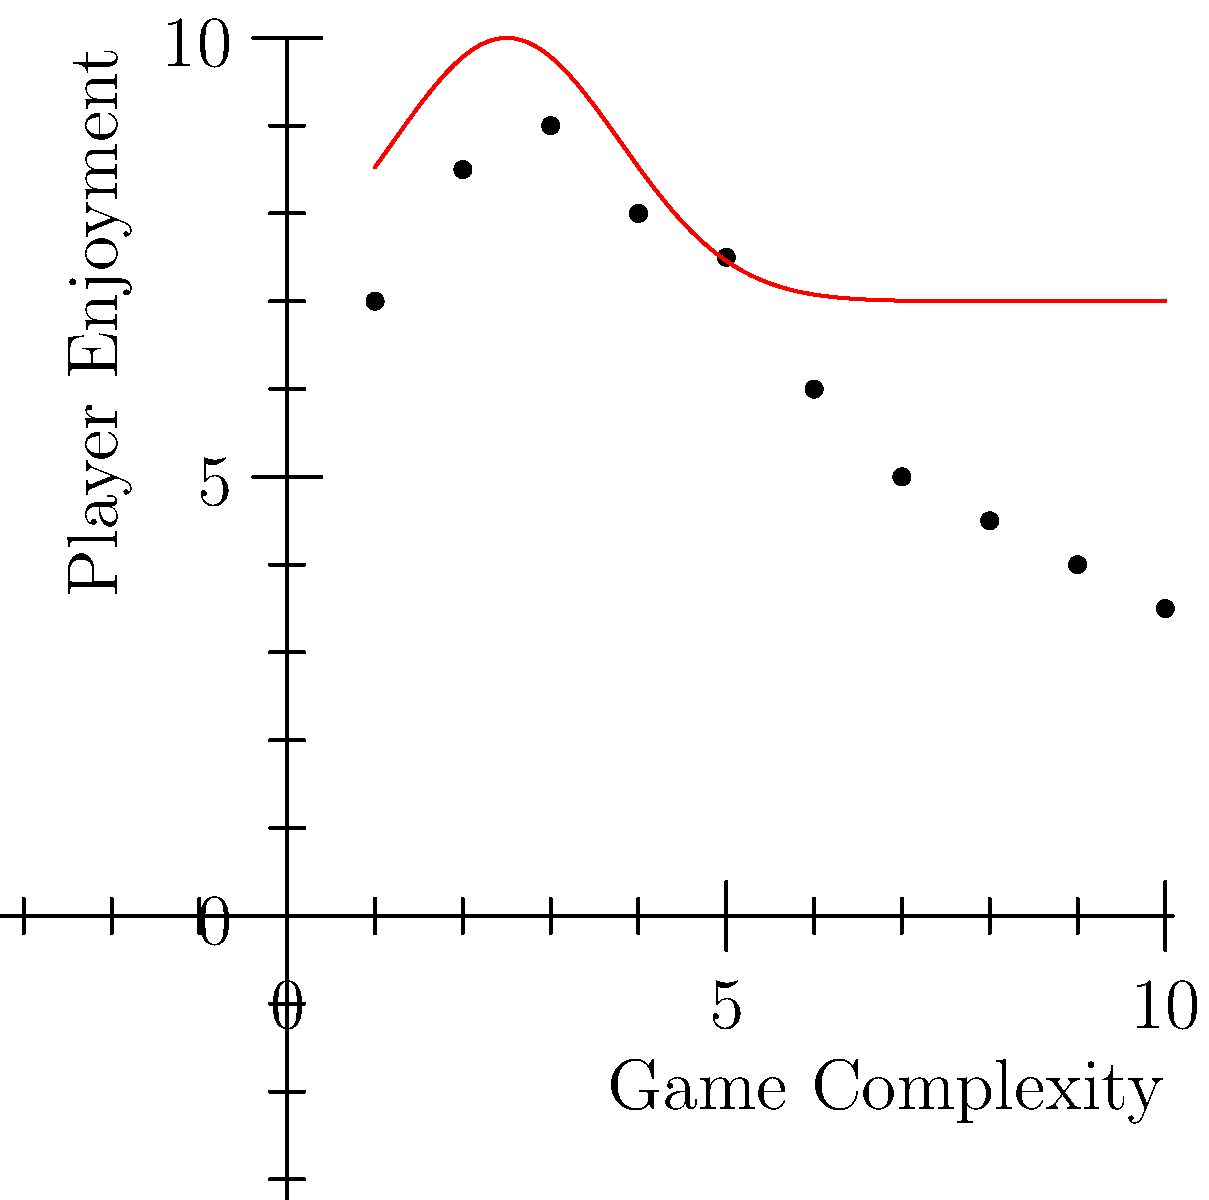Based on the scatter plot showing the relationship between game complexity and player enjoyment for classic games, what trend can be observed as game complexity increases? How does this support or challenge your belief about classic games offering a better experience? To answer this question, let's analyze the scatter plot step-by-step:

1. The x-axis represents game complexity, ranging from 1 (least complex) to 10 (most complex).
2. The y-axis represents player enjoyment, with higher values indicating greater enjoyment.

3. Observing the data points:
   - At low complexity (1-3), enjoyment increases rapidly.
   - Around medium complexity (3-5), enjoyment reaches its peak.
   - As complexity continues to increase (5-10), enjoyment gradually decreases.

4. The red curve represents the best-fit line for this data, clearly showing an inverted U-shape.

5. This trend suggests that:
   - Very simple games are not as enjoyable, possibly due to lack of challenge or engagement.
   - Games with moderate complexity are the most enjoyable, striking a balance between challenge and accessibility.
   - Highly complex games see a decline in enjoyment, possibly due to frustration or overwhelming gameplay.

6. For classic games:
   - Many classic games fall in the moderate complexity range, which aligns with the peak of enjoyment.
   - This supports the belief that classic games offer a better experience, as they often hit the "sweet spot" of complexity and enjoyment.
   - Classic games typically avoid extreme complexity, which according to this data, leads to decreased enjoyment.

7. However, it's important to note that this data doesn't directly compare classic to modern games, so it doesn't definitively prove that classic games are always better.
Answer: Inverted U-shape relationship; moderate complexity maximizes enjoyment, supporting the appeal of many classic games. 